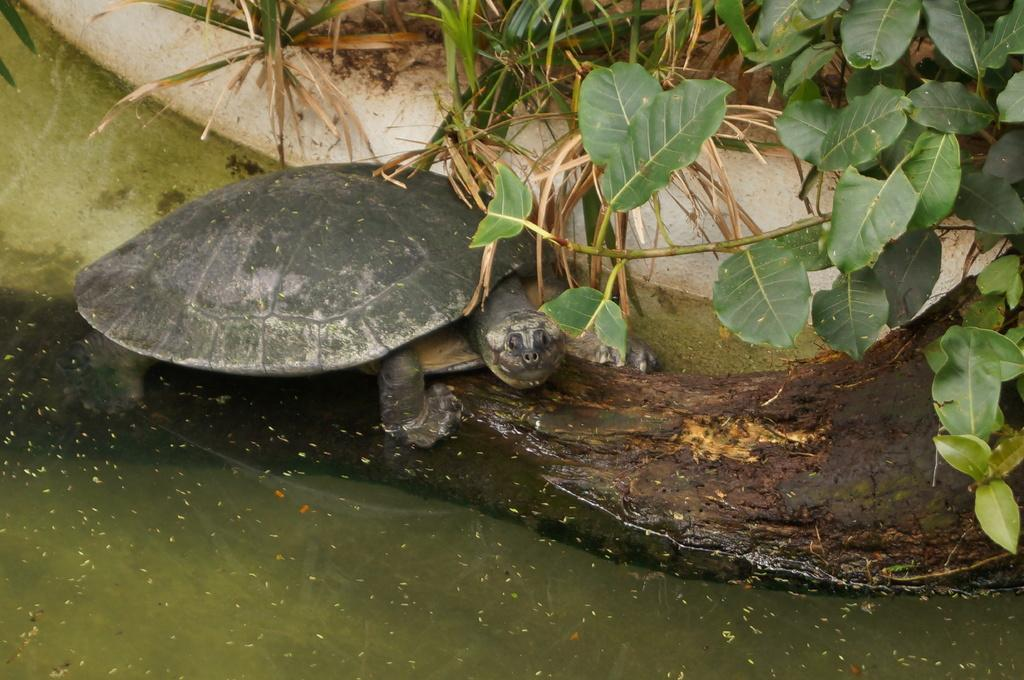What is the main element in the image? There is water in the image. What animal can be seen in the image? There is a tortoise present in the image. What is the color of the tortoise? The tortoise is black and ash in color. Where is the tortoise located in the image? The tortoise is on the ground. What type of vegetation is visible in the background of the image? There is green grass in the background of the image. What else can be seen in the background of the image? There are trees in the background of the image. What type of addition problem can be solved using the water in the image? There is no addition problem present in the image, as it features a tortoise and water. Can you see a volleyball being played in the image? There is no volleyball or any indication of a game being played in the image. 